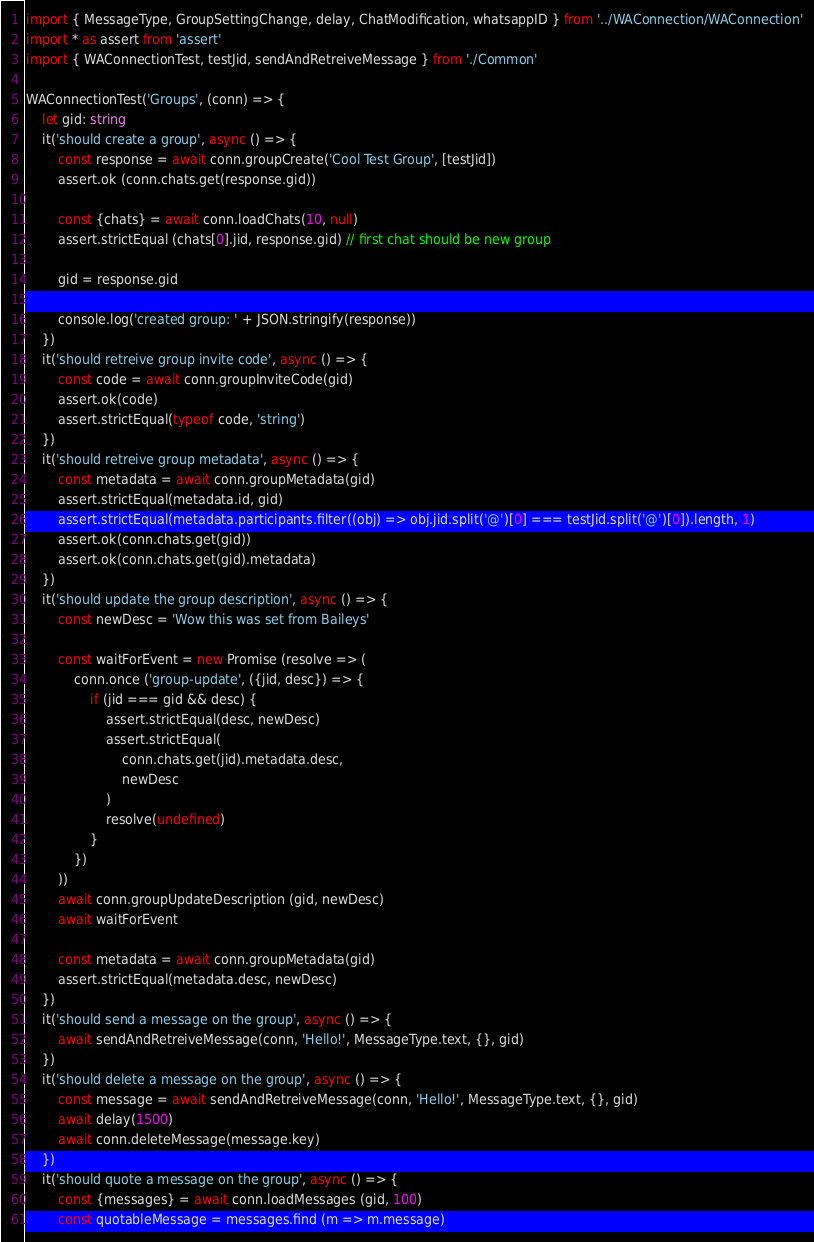<code> <loc_0><loc_0><loc_500><loc_500><_TypeScript_>import { MessageType, GroupSettingChange, delay, ChatModification, whatsappID } from '../WAConnection/WAConnection'
import * as assert from 'assert'
import { WAConnectionTest, testJid, sendAndRetreiveMessage } from './Common'

WAConnectionTest('Groups', (conn) => {
    let gid: string
    it('should create a group', async () => {
        const response = await conn.groupCreate('Cool Test Group', [testJid])
        assert.ok (conn.chats.get(response.gid))
        
        const {chats} = await conn.loadChats(10, null)
        assert.strictEqual (chats[0].jid, response.gid) // first chat should be new group

        gid = response.gid

        console.log('created group: ' + JSON.stringify(response))
    })
    it('should retreive group invite code', async () => {
        const code = await conn.groupInviteCode(gid)
        assert.ok(code)
        assert.strictEqual(typeof code, 'string')
    })
    it('should retreive group metadata', async () => {
        const metadata = await conn.groupMetadata(gid)
        assert.strictEqual(metadata.id, gid)
        assert.strictEqual(metadata.participants.filter((obj) => obj.jid.split('@')[0] === testJid.split('@')[0]).length, 1)
        assert.ok(conn.chats.get(gid))
        assert.ok(conn.chats.get(gid).metadata)
    })
    it('should update the group description', async () => {
        const newDesc = 'Wow this was set from Baileys'

        const waitForEvent = new Promise (resolve => (
            conn.once ('group-update', ({jid, desc}) => {
                if (jid === gid && desc) {
                    assert.strictEqual(desc, newDesc)
                    assert.strictEqual(
                        conn.chats.get(jid).metadata.desc,
                        newDesc
                    )
                    resolve(undefined)
                }
            })
        ))
        await conn.groupUpdateDescription (gid, newDesc)
        await waitForEvent

        const metadata = await conn.groupMetadata(gid)
        assert.strictEqual(metadata.desc, newDesc)
    })
    it('should send a message on the group', async () => {
        await sendAndRetreiveMessage(conn, 'Hello!', MessageType.text, {}, gid)
    })
    it('should delete a message on the group', async () => {
        const message = await sendAndRetreiveMessage(conn, 'Hello!', MessageType.text, {}, gid)
        await delay(1500)
        await conn.deleteMessage(message.key)
    })
    it('should quote a message on the group', async () => {
        const {messages} = await conn.loadMessages (gid, 100)
        const quotableMessage = messages.find (m => m.message)</code> 